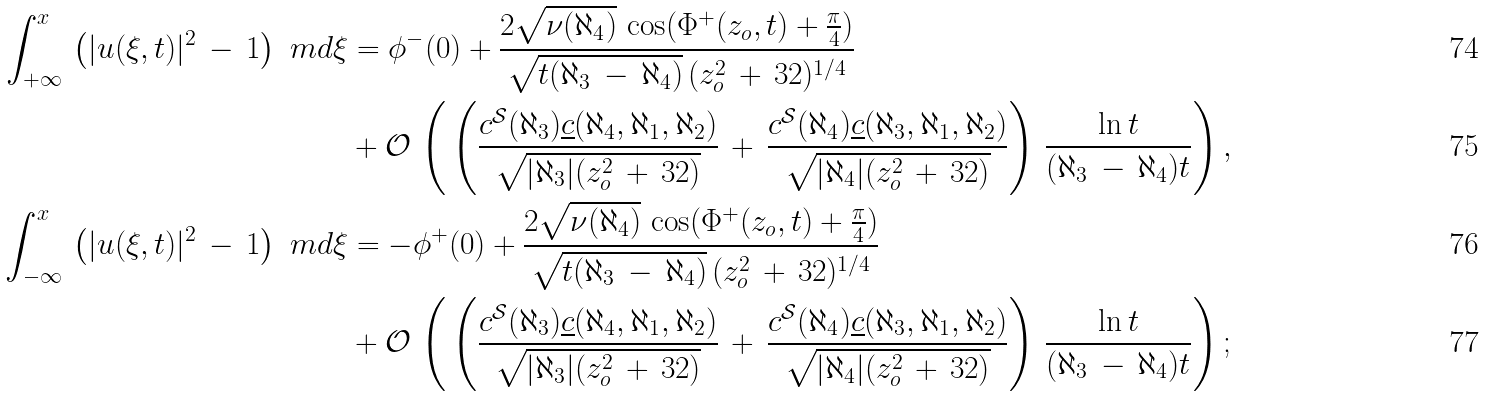<formula> <loc_0><loc_0><loc_500><loc_500>\int _ { + \infty } ^ { x } \, \left ( | u ( \xi , t ) | ^ { 2 } \, - \, 1 \right ) \ m d \xi & = \phi ^ { - } ( 0 ) + \frac { 2 \sqrt { \nu ( \aleph _ { 4 } ) } \, \cos ( \Phi ^ { + } ( z _ { o } , t ) + \frac { \pi } { 4 } ) } { \sqrt { t ( \aleph _ { 3 } \, - \, \aleph _ { 4 } ) } \, ( z _ { o } ^ { 2 } \, + \, 3 2 ) ^ { 1 / 4 } } \\ & + \mathcal { O } \, \left ( \, \left ( \frac { c ^ { \mathcal { S } } ( \aleph _ { 3 } ) \underline { c } ( \aleph _ { 4 } , \aleph _ { 1 } , \aleph _ { 2 } ) } { \sqrt { | \aleph _ { 3 } | ( z _ { o } ^ { 2 } \, + \, 3 2 ) } } \, + \, \frac { c ^ { \mathcal { S } } ( \aleph _ { 4 } ) \underline { c } ( \aleph _ { 3 } , \aleph _ { 1 } , \aleph _ { 2 } ) } { \sqrt { | \aleph _ { 4 } | ( z _ { o } ^ { 2 } \, + \, 3 2 ) } } \right ) \, \frac { \ln t } { ( \aleph _ { 3 } \, - \, \aleph _ { 4 } ) t } \right ) , \\ \int _ { - \infty } ^ { x } \, \left ( | u ( \xi , t ) | ^ { 2 } \, - \, 1 \right ) \ m d \xi & = - \phi ^ { + } ( 0 ) + \frac { 2 \sqrt { \nu ( \aleph _ { 4 } ) } \, \cos ( \Phi ^ { + } ( z _ { o } , t ) + \frac { \pi } { 4 } ) } { \sqrt { t ( \aleph _ { 3 } \, - \, \aleph _ { 4 } ) } \, ( z _ { o } ^ { 2 } \, + \, 3 2 ) ^ { 1 / 4 } } \\ & + \mathcal { O } \, \left ( \, \left ( \frac { c ^ { \mathcal { S } } ( \aleph _ { 3 } ) \underline { c } ( \aleph _ { 4 } , \aleph _ { 1 } , \aleph _ { 2 } ) } { \sqrt { | \aleph _ { 3 } | ( z _ { o } ^ { 2 } \, + \, 3 2 ) } } \, + \, \frac { c ^ { \mathcal { S } } ( \aleph _ { 4 } ) \underline { c } ( \aleph _ { 3 } , \aleph _ { 1 } , \aleph _ { 2 } ) } { \sqrt { | \aleph _ { 4 } | ( z _ { o } ^ { 2 } \, + \, 3 2 ) } } \right ) \, \frac { \ln t } { ( \aleph _ { 3 } \, - \, \aleph _ { 4 } ) t } \right ) ;</formula> 